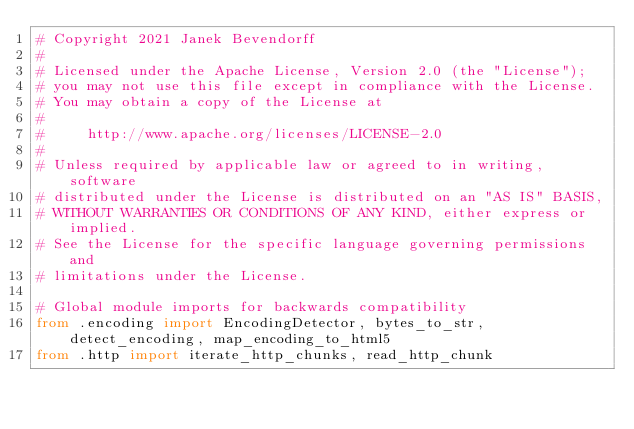Convert code to text. <code><loc_0><loc_0><loc_500><loc_500><_Python_># Copyright 2021 Janek Bevendorff
#
# Licensed under the Apache License, Version 2.0 (the "License");
# you may not use this file except in compliance with the License.
# You may obtain a copy of the License at
#
#     http://www.apache.org/licenses/LICENSE-2.0
#
# Unless required by applicable law or agreed to in writing, software
# distributed under the License is distributed on an "AS IS" BASIS,
# WITHOUT WARRANTIES OR CONDITIONS OF ANY KIND, either express or implied.
# See the License for the specific language governing permissions and
# limitations under the License.

# Global module imports for backwards compatibility
from .encoding import EncodingDetector, bytes_to_str, detect_encoding, map_encoding_to_html5
from .http import iterate_http_chunks, read_http_chunk
</code> 